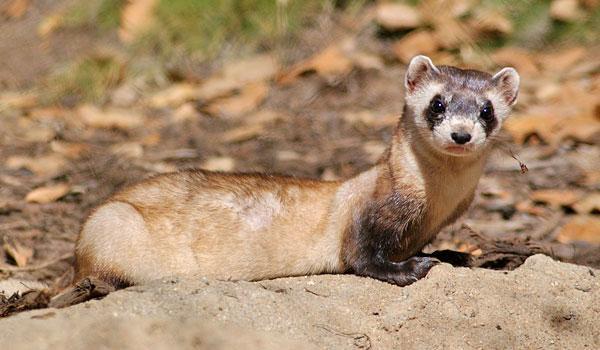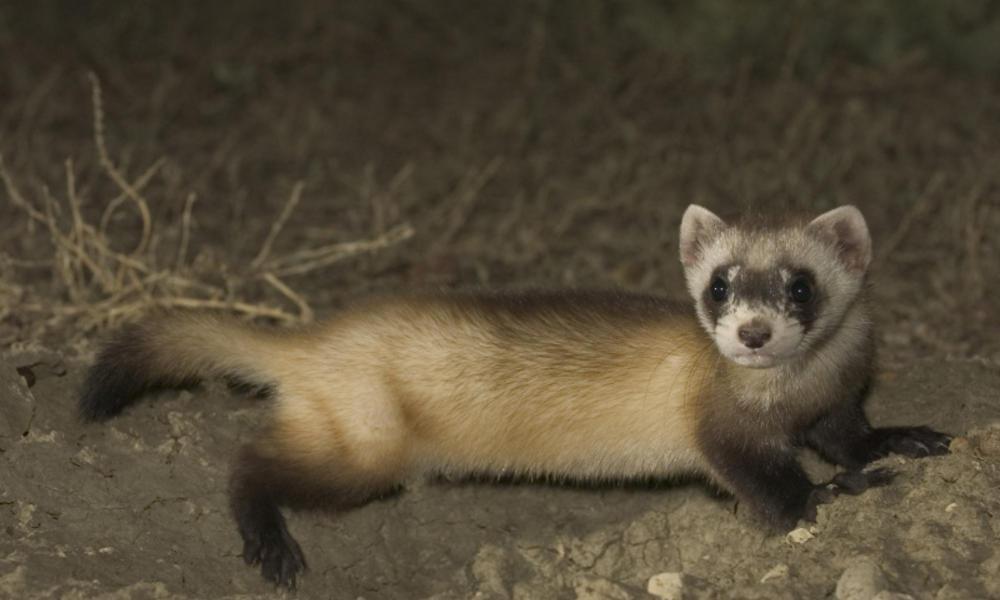The first image is the image on the left, the second image is the image on the right. Evaluate the accuracy of this statement regarding the images: "Every image in the set contains a single ferret, in an outdoor setting.". Is it true? Answer yes or no. Yes. The first image is the image on the left, the second image is the image on the right. Assess this claim about the two images: "There are exactly two ferrets outdoors.". Correct or not? Answer yes or no. Yes. 